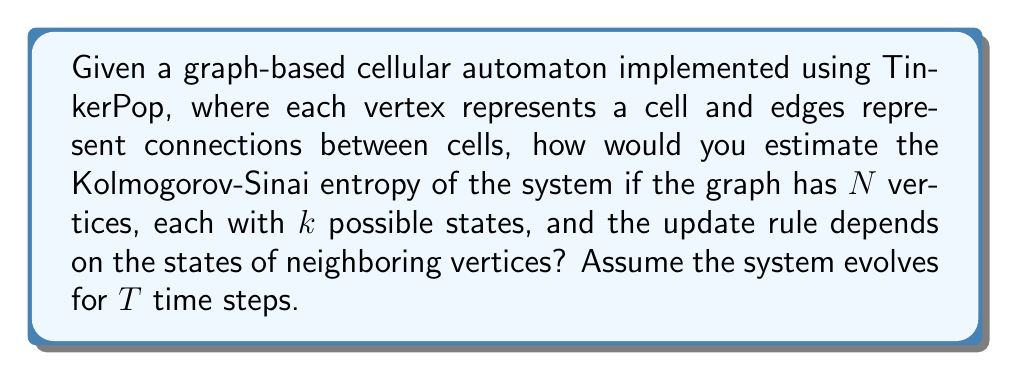Show me your answer to this math problem. To estimate the Kolmogorov-Sinai entropy of a graph-based cellular automaton using TinkerPop, we can follow these steps:

1. Represent the cellular automaton as a graph:
   - Use TinkerPop's Graph API to create vertices (cells) and edges (connections).
   - Each vertex has a property representing its current state (out of $k$ possible states).

2. Implement the update rule:
   - Use TinkerPop's traversal API to access neighboring vertices and their states.
   - Apply the rule to determine the next state of each vertex.

3. Estimate the Kolmogorov-Sinai entropy:
   a. Generate a long sequence of states by evolving the system for $T$ time steps.
   b. For each time step $t$, compute the frequency of each possible state configuration:
      $$p_i(t) = \frac{\text{number of occurrences of state } i}{\text{total number of vertices}}$$
   c. Calculate the Shannon entropy for each time step:
      $$H(t) = -\sum_{i=1}^k p_i(t) \log_2 p_i(t)$$
   d. Estimate the Kolmogorov-Sinai entropy as the average rate of entropy increase:
      $$h_{KS} \approx \frac{H(T) - H(0)}{T}$$

4. Implement this calculation using TinkerPop's GraphComputer for parallel processing:
   - Use a VertexProgram to update states and collect statistics.
   - Use a MapReduce job to aggregate results and compute the final entropy estimate.

5. Refine the estimate:
   - Repeat the process for different initial conditions and longer time periods.
   - Take the average of multiple runs to improve accuracy.

The Kolmogorov-Sinai entropy quantifies the rate of information production in the system. A positive value indicates chaotic behavior, while a value of zero suggests regular or periodic behavior.
Answer: $$h_{KS} \approx \frac{H(T) - H(0)}{T}$$ 